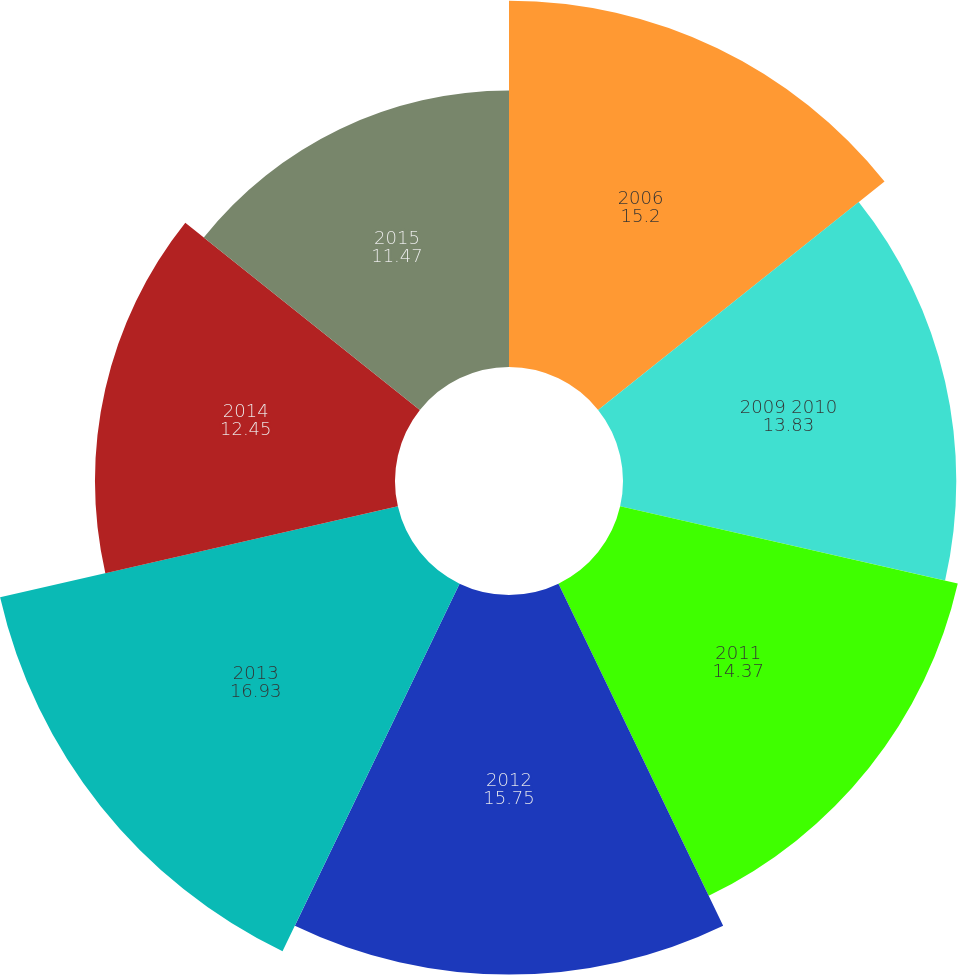Convert chart to OTSL. <chart><loc_0><loc_0><loc_500><loc_500><pie_chart><fcel>2006<fcel>2009 2010<fcel>2011<fcel>2012<fcel>2013<fcel>2014<fcel>2015<nl><fcel>15.2%<fcel>13.83%<fcel>14.37%<fcel>15.75%<fcel>16.93%<fcel>12.45%<fcel>11.47%<nl></chart> 